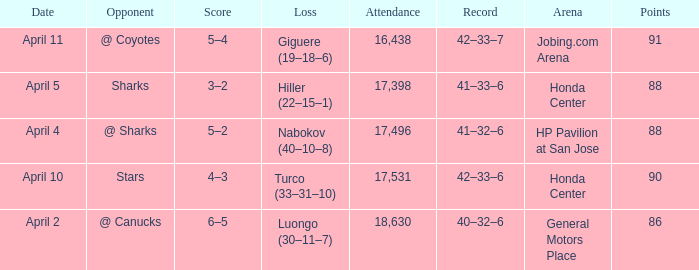On what date was the Record 41–32–6? April 4. 